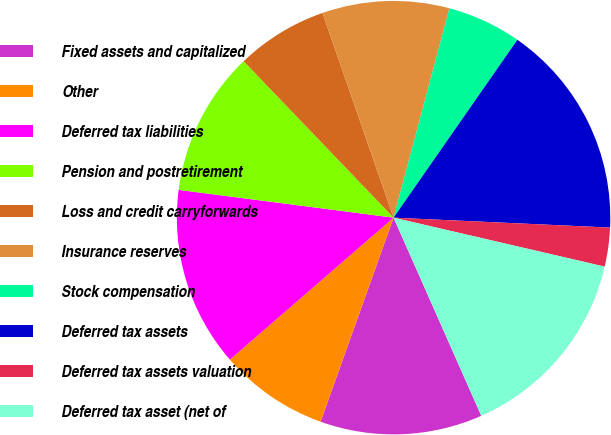Convert chart to OTSL. <chart><loc_0><loc_0><loc_500><loc_500><pie_chart><fcel>Fixed assets and capitalized<fcel>Other<fcel>Deferred tax liabilities<fcel>Pension and postretirement<fcel>Loss and credit carryforwards<fcel>Insurance reserves<fcel>Stock compensation<fcel>Deferred tax assets<fcel>Deferred tax assets valuation<fcel>Deferred tax asset (net of<nl><fcel>12.1%<fcel>8.16%<fcel>13.42%<fcel>10.79%<fcel>6.84%<fcel>9.47%<fcel>5.53%<fcel>16.05%<fcel>2.9%<fcel>14.74%<nl></chart> 